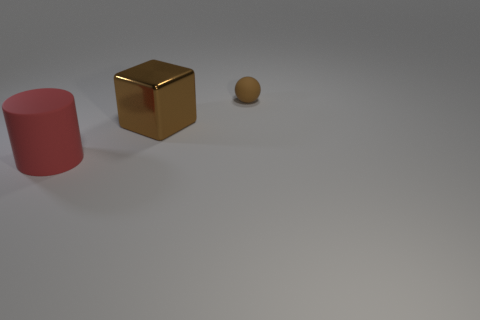What number of big cubes are the same color as the rubber ball?
Offer a very short reply. 1. What number of big cylinders are left of the large object behind the cylinder?
Your answer should be compact. 1. Is the size of the rubber cylinder the same as the brown sphere?
Your response must be concise. No. How many big brown things have the same material as the cylinder?
Ensure brevity in your answer.  0. There is a object that is in front of the large brown cube; does it have the same shape as the brown shiny object?
Provide a short and direct response. No. There is a brown thing that is in front of the rubber object behind the big brown block; what shape is it?
Offer a terse response. Cube. Is there any other thing that has the same shape as the red thing?
Your answer should be very brief. No. There is a large shiny cube; is it the same color as the matte thing on the right side of the red rubber thing?
Provide a short and direct response. Yes. The object that is both behind the big red thing and on the left side of the matte sphere has what shape?
Offer a very short reply. Cube. Is the number of things less than the number of large cylinders?
Your answer should be compact. No. 